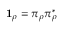Convert formula to latex. <formula><loc_0><loc_0><loc_500><loc_500>{ 1 } _ { \rho } = \pi _ { \rho } \pi _ { \rho } ^ { * }</formula> 